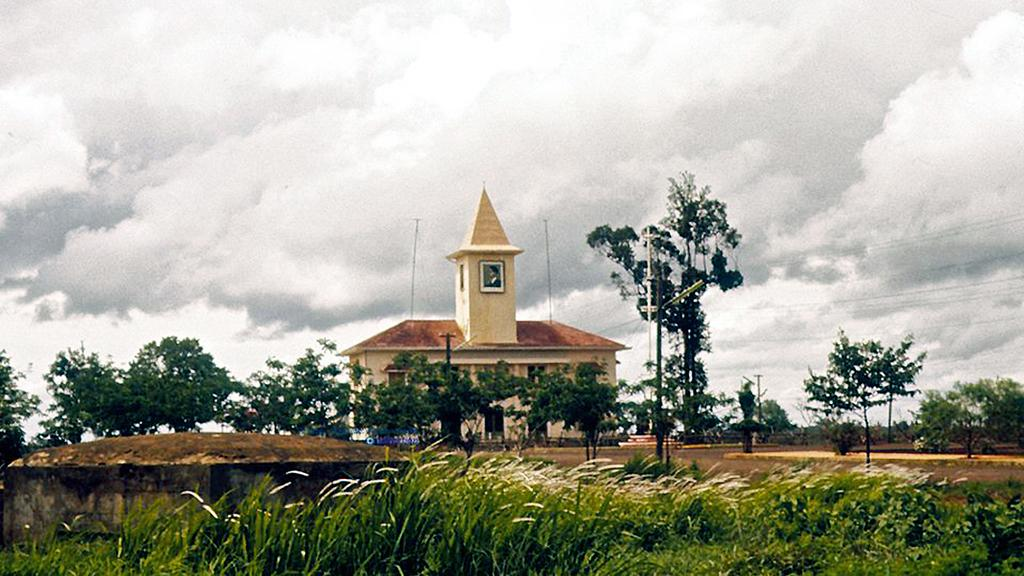What type of structure is visible in the image? There is a house in the image. What is the landscape surrounding the house? The house is surrounded by grass fields. Are there any other natural elements in the image? Yes, there are trees in the image. What type of pathway can be seen in the image? There is a road in the image. How would you describe the weather based on the image? The sky is cloudy in the image. What type of earth treatment is being performed on the grass fields in the image? There is no indication of any earth treatment being performed in the image; it simply shows a house surrounded by grass fields. 